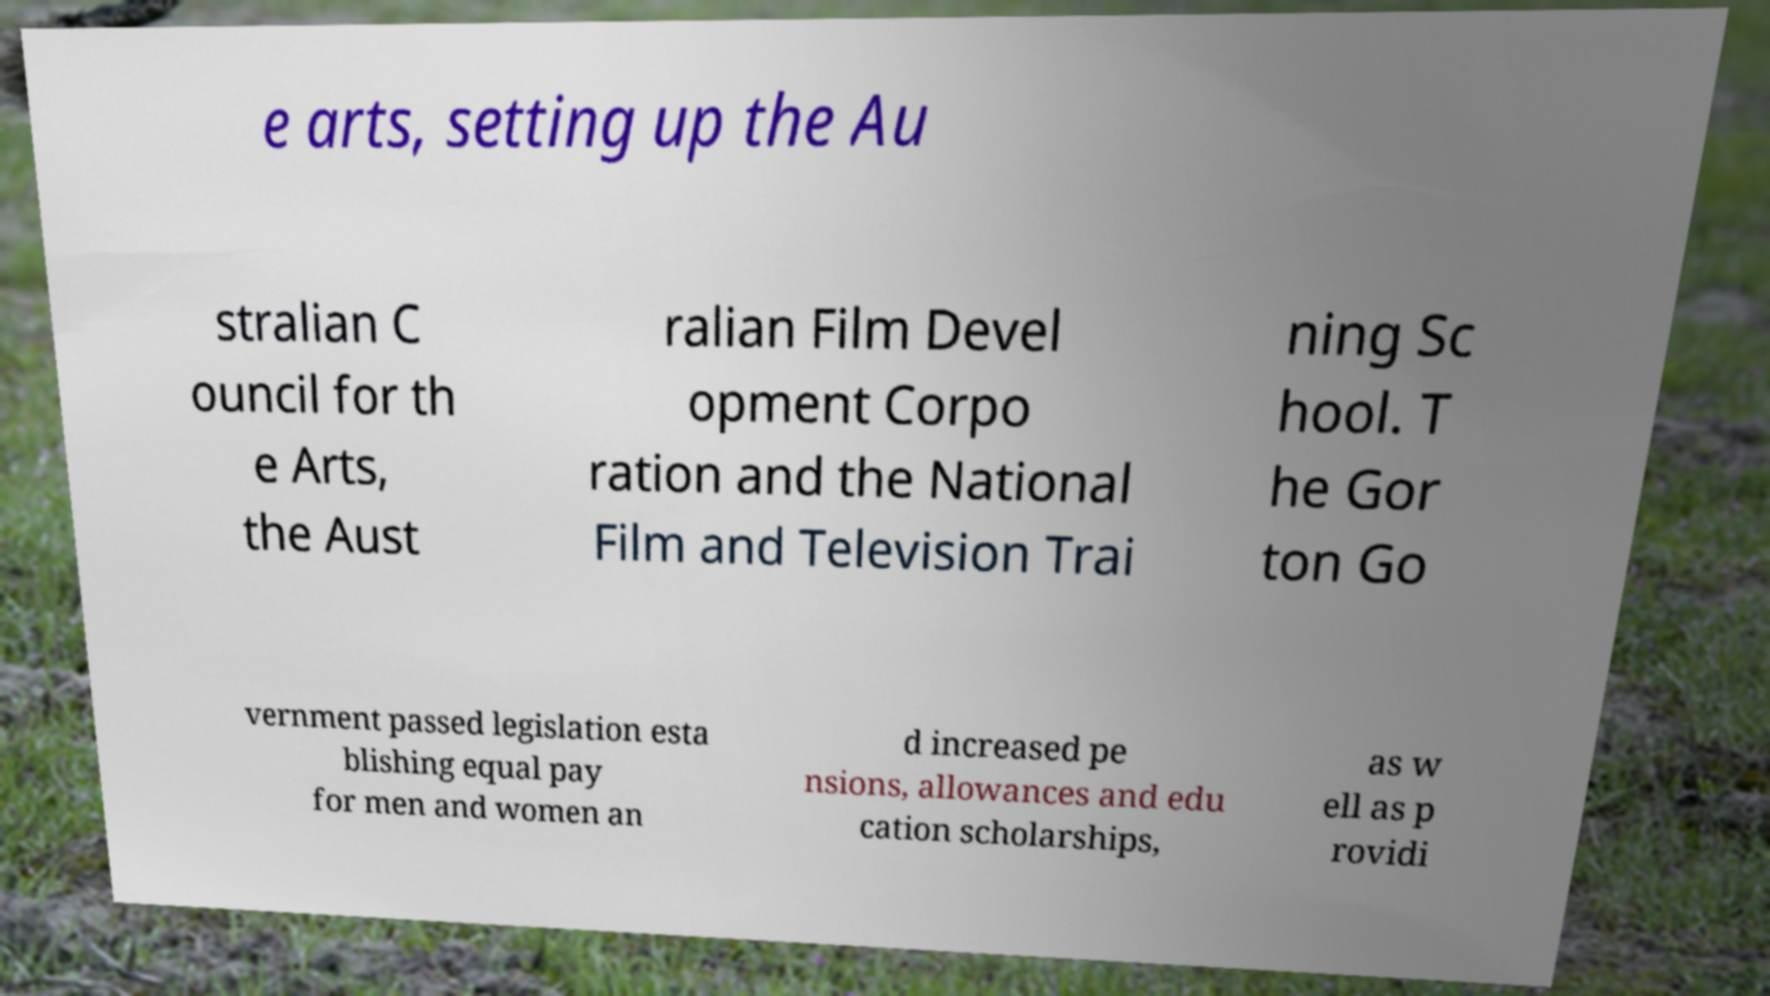Could you assist in decoding the text presented in this image and type it out clearly? e arts, setting up the Au stralian C ouncil for th e Arts, the Aust ralian Film Devel opment Corpo ration and the National Film and Television Trai ning Sc hool. T he Gor ton Go vernment passed legislation esta blishing equal pay for men and women an d increased pe nsions, allowances and edu cation scholarships, as w ell as p rovidi 